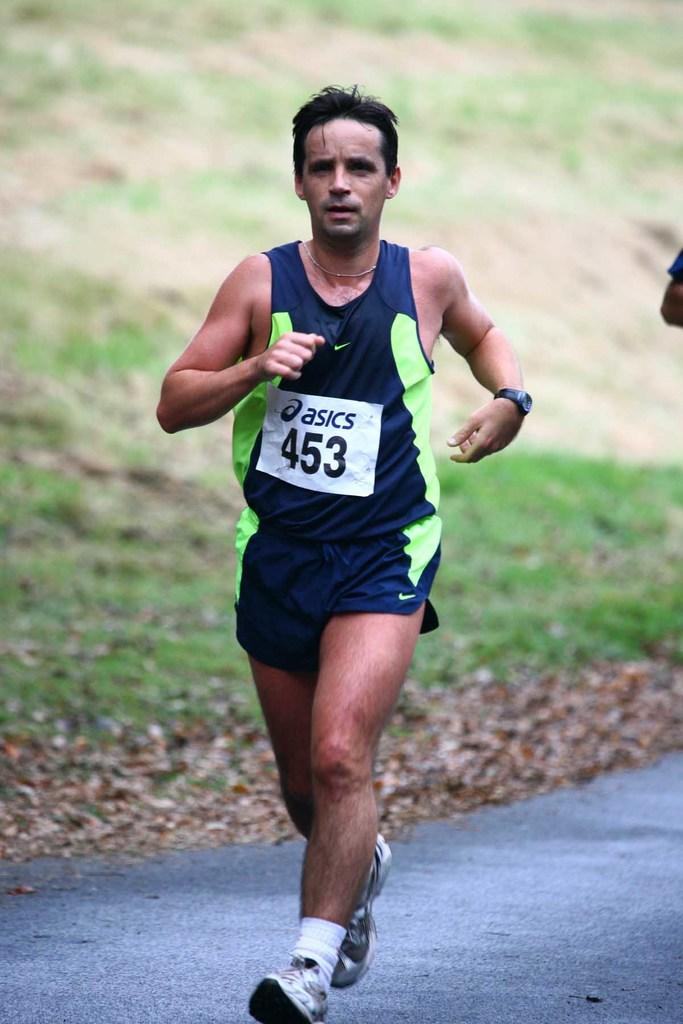<image>
Provide a brief description of the given image. The athlete is wearing a number 453 tag. 